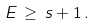<formula> <loc_0><loc_0><loc_500><loc_500>E \, \geq \, s + 1 \, .</formula> 